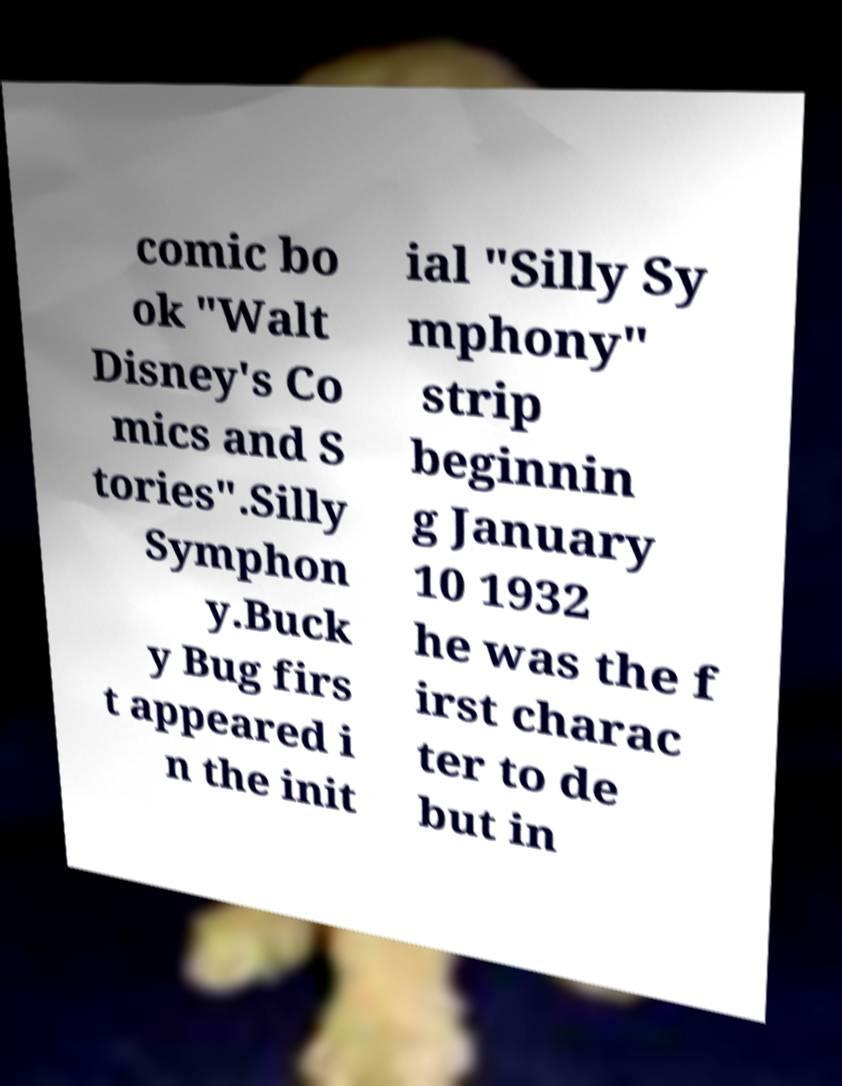Can you accurately transcribe the text from the provided image for me? comic bo ok "Walt Disney's Co mics and S tories".Silly Symphon y.Buck y Bug firs t appeared i n the init ial "Silly Sy mphony" strip beginnin g January 10 1932 he was the f irst charac ter to de but in 